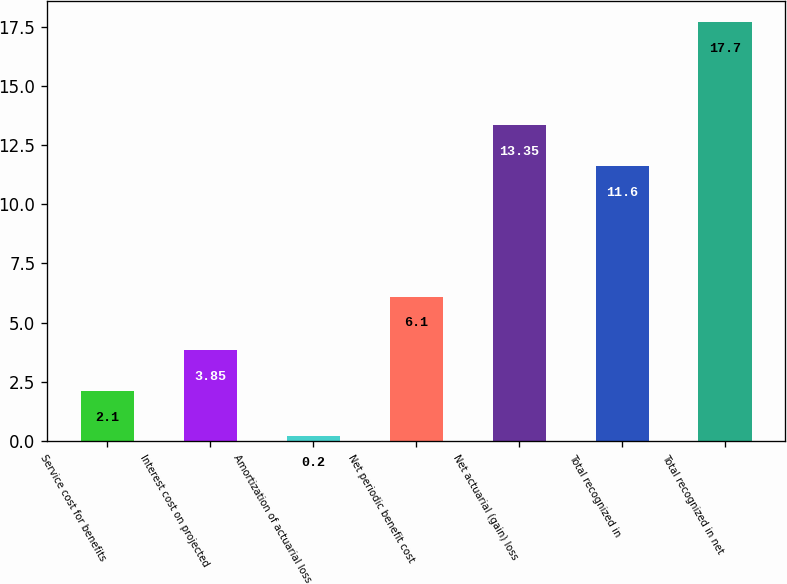<chart> <loc_0><loc_0><loc_500><loc_500><bar_chart><fcel>Service cost for benefits<fcel>Interest cost on projected<fcel>Amortization of actuarial loss<fcel>Net periodic benefit cost<fcel>Net actuarial (gain) loss<fcel>Total recognized in<fcel>Total recognized in net<nl><fcel>2.1<fcel>3.85<fcel>0.2<fcel>6.1<fcel>13.35<fcel>11.6<fcel>17.7<nl></chart> 